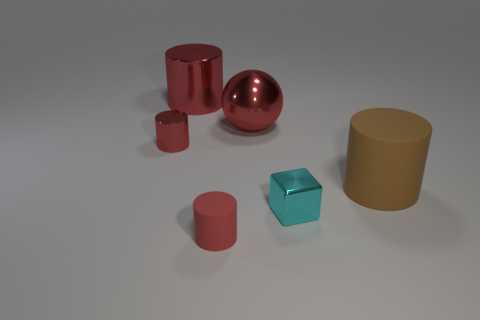There is a shiny thing right of the big sphere that is behind the tiny red shiny cylinder; what number of large matte things are behind it?
Your answer should be compact. 1. What is the size of the cyan shiny object?
Keep it short and to the point. Small. Do the tiny metallic cylinder and the tiny matte cylinder have the same color?
Keep it short and to the point. Yes. There is a red shiny object in front of the red sphere; what size is it?
Your response must be concise. Small. Is the color of the matte cylinder that is in front of the shiny block the same as the big shiny ball behind the large brown matte cylinder?
Keep it short and to the point. Yes. How many other objects are the same shape as the tiny red matte object?
Provide a succinct answer. 3. Are there an equal number of blocks behind the small block and large red shiny things in front of the big red cylinder?
Ensure brevity in your answer.  No. Does the small red object that is in front of the metal cube have the same material as the large cylinder behind the large shiny sphere?
Offer a very short reply. No. What number of things are cyan things or shiny things on the left side of the cyan cube?
Your response must be concise. 4. Are there an equal number of large objects in front of the tiny cyan block and large blue things?
Offer a very short reply. Yes. 